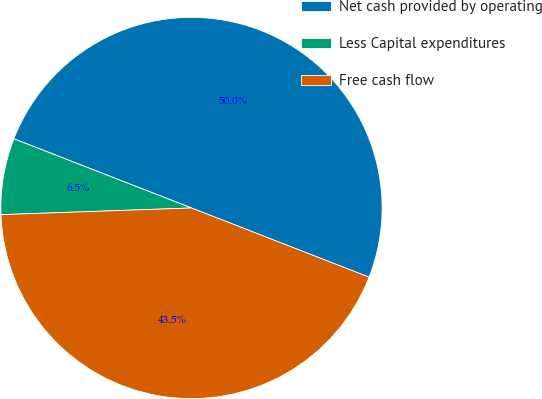Convert chart. <chart><loc_0><loc_0><loc_500><loc_500><pie_chart><fcel>Net cash provided by operating<fcel>Less Capital expenditures<fcel>Free cash flow<nl><fcel>50.0%<fcel>6.47%<fcel>43.53%<nl></chart> 